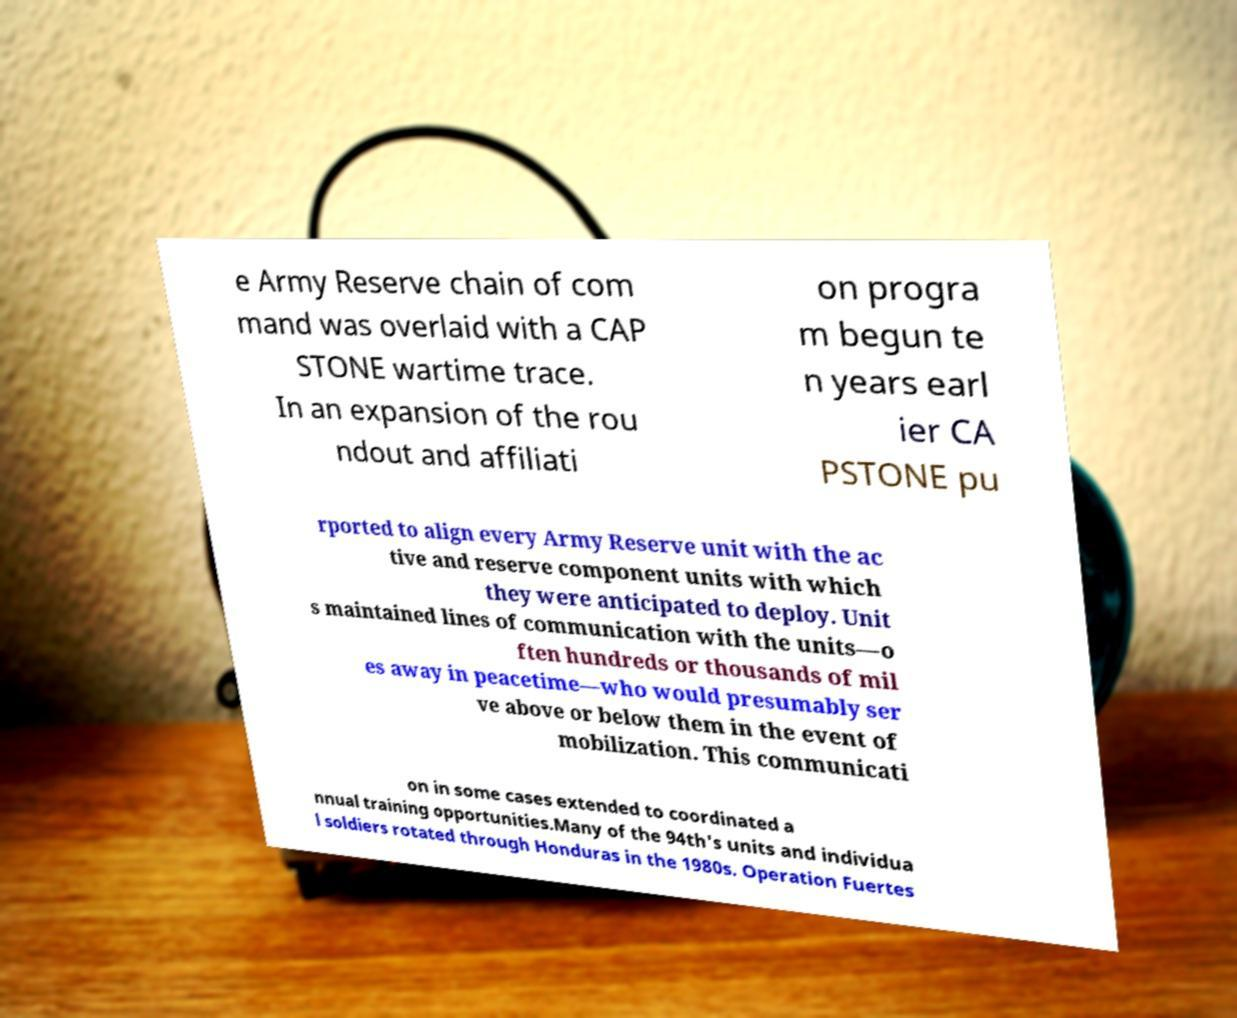Can you read and provide the text displayed in the image?This photo seems to have some interesting text. Can you extract and type it out for me? e Army Reserve chain of com mand was overlaid with a CAP STONE wartime trace. In an expansion of the rou ndout and affiliati on progra m begun te n years earl ier CA PSTONE pu rported to align every Army Reserve unit with the ac tive and reserve component units with which they were anticipated to deploy. Unit s maintained lines of communication with the units—o ften hundreds or thousands of mil es away in peacetime—who would presumably ser ve above or below them in the event of mobilization. This communicati on in some cases extended to coordinated a nnual training opportunities.Many of the 94th's units and individua l soldiers rotated through Honduras in the 1980s. Operation Fuertes 